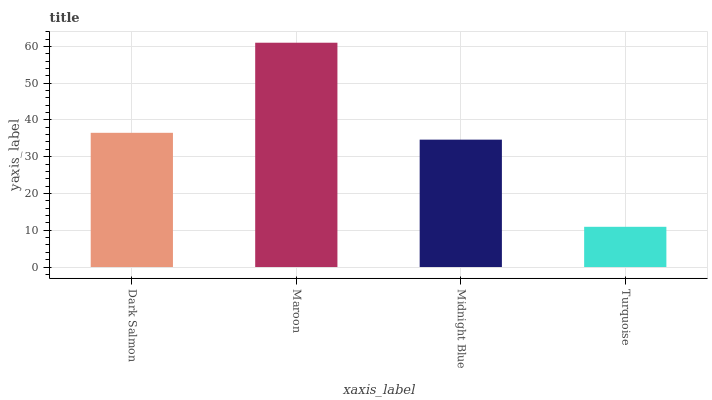Is Turquoise the minimum?
Answer yes or no. Yes. Is Maroon the maximum?
Answer yes or no. Yes. Is Midnight Blue the minimum?
Answer yes or no. No. Is Midnight Blue the maximum?
Answer yes or no. No. Is Maroon greater than Midnight Blue?
Answer yes or no. Yes. Is Midnight Blue less than Maroon?
Answer yes or no. Yes. Is Midnight Blue greater than Maroon?
Answer yes or no. No. Is Maroon less than Midnight Blue?
Answer yes or no. No. Is Dark Salmon the high median?
Answer yes or no. Yes. Is Midnight Blue the low median?
Answer yes or no. Yes. Is Midnight Blue the high median?
Answer yes or no. No. Is Maroon the low median?
Answer yes or no. No. 